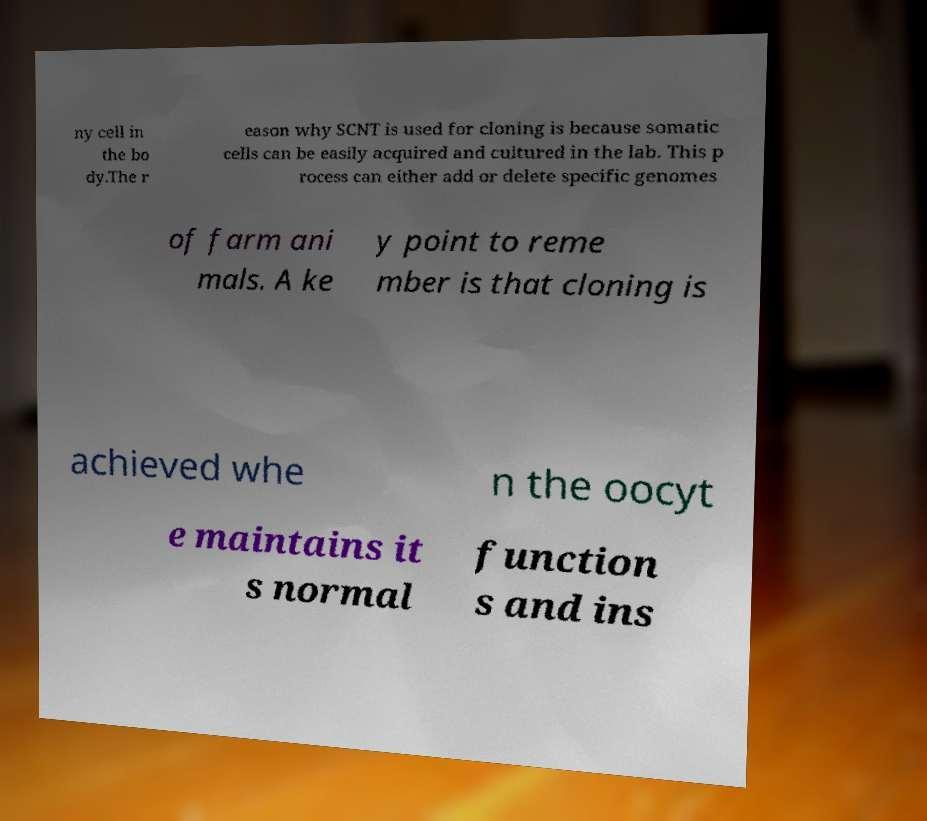Can you read and provide the text displayed in the image?This photo seems to have some interesting text. Can you extract and type it out for me? ny cell in the bo dy.The r eason why SCNT is used for cloning is because somatic cells can be easily acquired and cultured in the lab. This p rocess can either add or delete specific genomes of farm ani mals. A ke y point to reme mber is that cloning is achieved whe n the oocyt e maintains it s normal function s and ins 